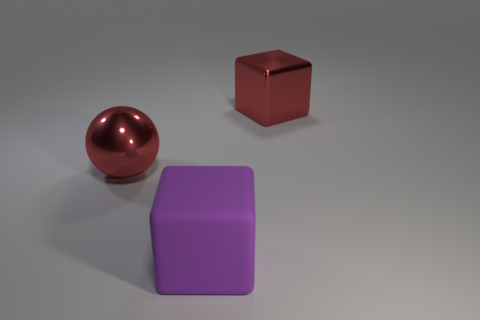Add 1 red metal balls. How many objects exist? 4 Subtract all gray spheres. Subtract all red cubes. How many spheres are left? 1 Subtract all tiny yellow things. Subtract all big purple cubes. How many objects are left? 2 Add 3 red metallic spheres. How many red metallic spheres are left? 4 Add 1 gray rubber blocks. How many gray rubber blocks exist? 1 Subtract 0 yellow cylinders. How many objects are left? 3 Subtract all spheres. How many objects are left? 2 